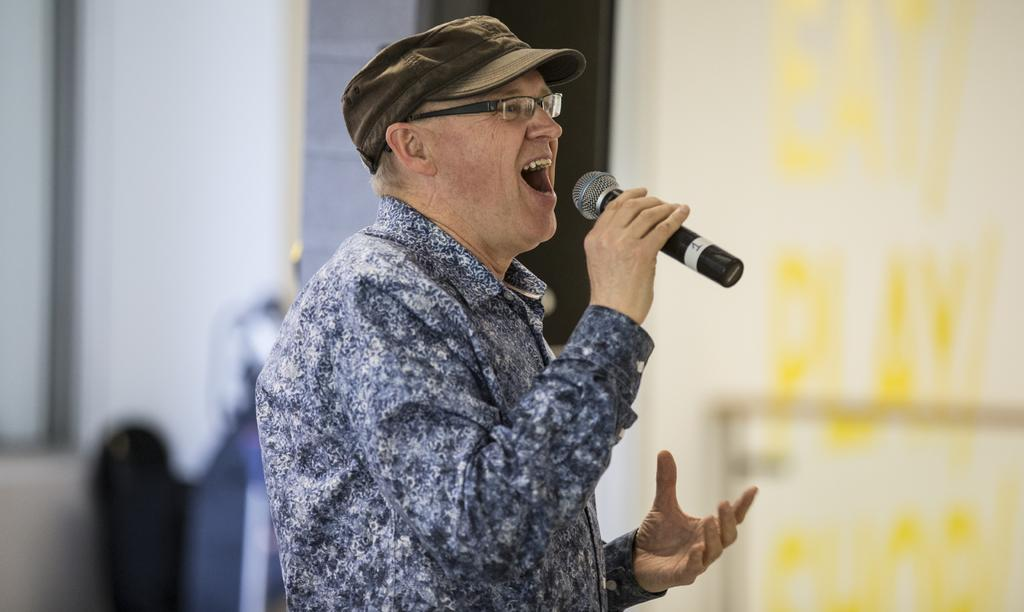What can be seen in the image? There is a person in the image. Can you describe the person's appearance? The person is wearing a cap and spectacles. What is the person holding in the image? The person is holding a microphone (mike). How would you describe the background of the image? The background of the image is blurry. What type of structure can be seen in the background of the image? There is no structure visible in the background of the image; it is blurry. Can you spot any deer in the image? There are no deer present in the image. Is there an ant crawling on the person's cap in the image? There is no ant visible on the person's cap in the image. 